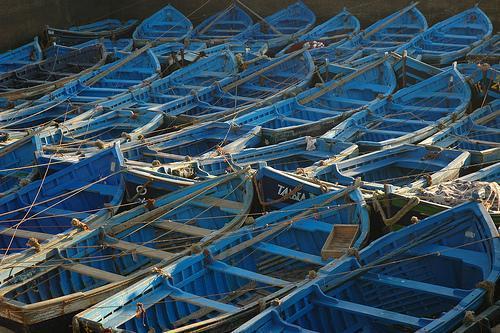How many little wooden boxes are in the image?
Give a very brief answer. 1. 